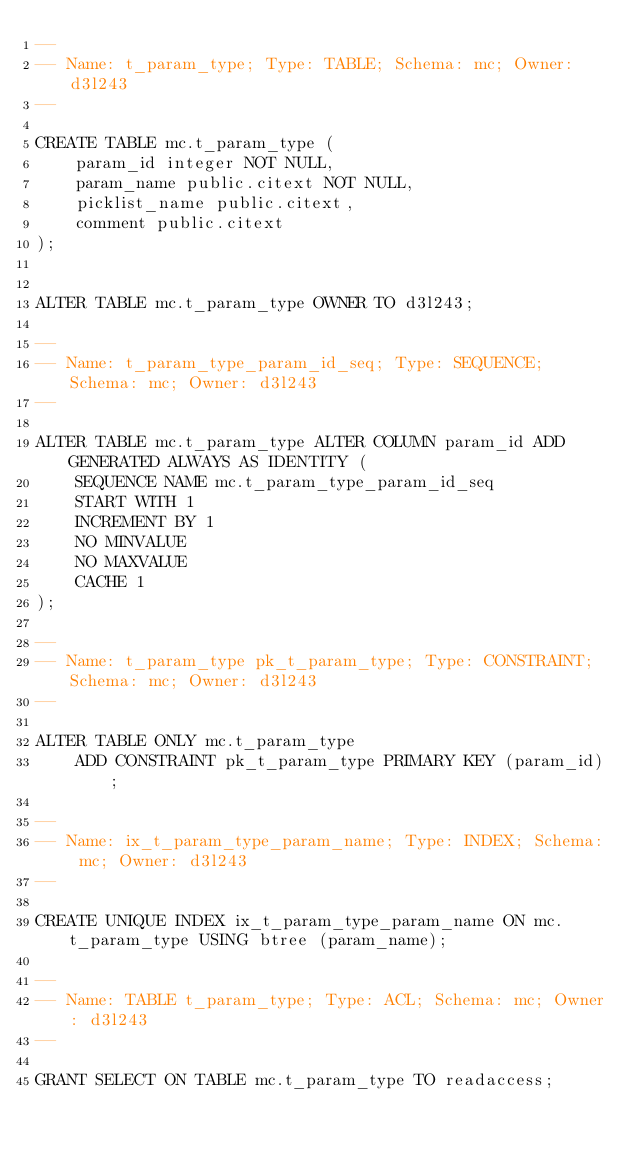Convert code to text. <code><loc_0><loc_0><loc_500><loc_500><_SQL_>--
-- Name: t_param_type; Type: TABLE; Schema: mc; Owner: d3l243
--

CREATE TABLE mc.t_param_type (
    param_id integer NOT NULL,
    param_name public.citext NOT NULL,
    picklist_name public.citext,
    comment public.citext
);


ALTER TABLE mc.t_param_type OWNER TO d3l243;

--
-- Name: t_param_type_param_id_seq; Type: SEQUENCE; Schema: mc; Owner: d3l243
--

ALTER TABLE mc.t_param_type ALTER COLUMN param_id ADD GENERATED ALWAYS AS IDENTITY (
    SEQUENCE NAME mc.t_param_type_param_id_seq
    START WITH 1
    INCREMENT BY 1
    NO MINVALUE
    NO MAXVALUE
    CACHE 1
);

--
-- Name: t_param_type pk_t_param_type; Type: CONSTRAINT; Schema: mc; Owner: d3l243
--

ALTER TABLE ONLY mc.t_param_type
    ADD CONSTRAINT pk_t_param_type PRIMARY KEY (param_id);

--
-- Name: ix_t_param_type_param_name; Type: INDEX; Schema: mc; Owner: d3l243
--

CREATE UNIQUE INDEX ix_t_param_type_param_name ON mc.t_param_type USING btree (param_name);

--
-- Name: TABLE t_param_type; Type: ACL; Schema: mc; Owner: d3l243
--

GRANT SELECT ON TABLE mc.t_param_type TO readaccess;

</code> 